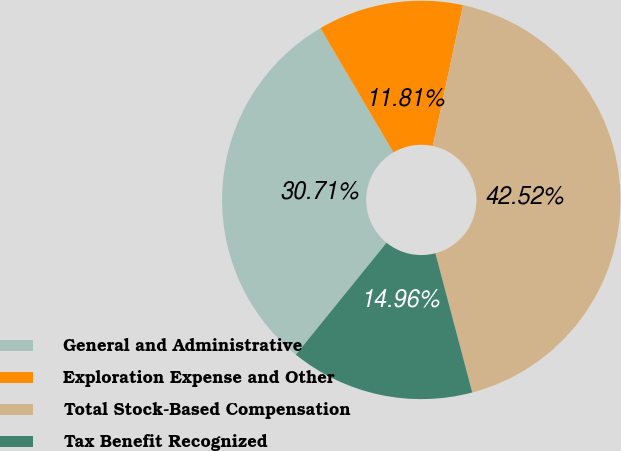Convert chart to OTSL. <chart><loc_0><loc_0><loc_500><loc_500><pie_chart><fcel>General and Administrative<fcel>Exploration Expense and Other<fcel>Total Stock-Based Compensation<fcel>Tax Benefit Recognized<nl><fcel>30.71%<fcel>11.81%<fcel>42.52%<fcel>14.96%<nl></chart> 